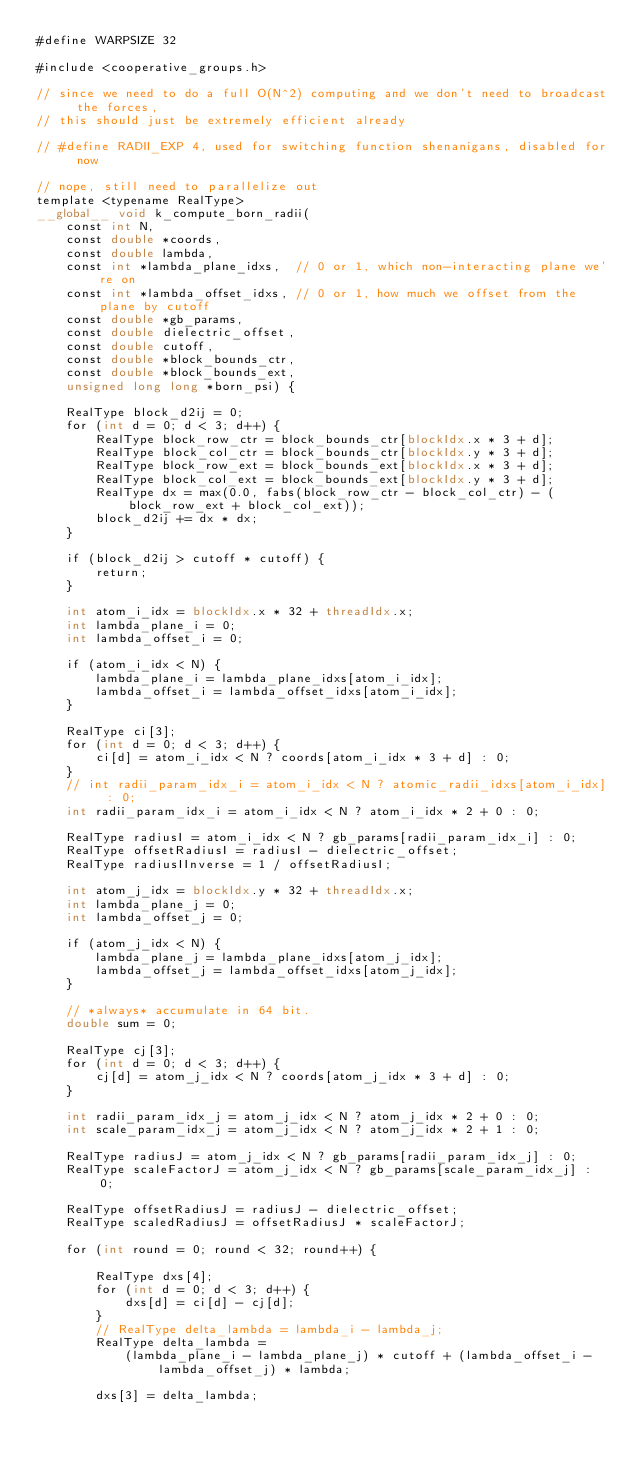<code> <loc_0><loc_0><loc_500><loc_500><_Cuda_>#define WARPSIZE 32

#include <cooperative_groups.h>

// since we need to do a full O(N^2) computing and we don't need to broadcast the forces,
// this should just be extremely efficient already

// #define RADII_EXP 4, used for switching function shenanigans, disabled for now

// nope, still need to parallelize out
template <typename RealType>
__global__ void k_compute_born_radii(
    const int N,
    const double *coords,
    const double lambda,
    const int *lambda_plane_idxs,  // 0 or 1, which non-interacting plane we're on
    const int *lambda_offset_idxs, // 0 or 1, how much we offset from the plane by cutoff
    const double *gb_params,
    const double dielectric_offset,
    const double cutoff,
    const double *block_bounds_ctr,
    const double *block_bounds_ext,
    unsigned long long *born_psi) {

    RealType block_d2ij = 0;
    for (int d = 0; d < 3; d++) {
        RealType block_row_ctr = block_bounds_ctr[blockIdx.x * 3 + d];
        RealType block_col_ctr = block_bounds_ctr[blockIdx.y * 3 + d];
        RealType block_row_ext = block_bounds_ext[blockIdx.x * 3 + d];
        RealType block_col_ext = block_bounds_ext[blockIdx.y * 3 + d];
        RealType dx = max(0.0, fabs(block_row_ctr - block_col_ctr) - (block_row_ext + block_col_ext));
        block_d2ij += dx * dx;
    }

    if (block_d2ij > cutoff * cutoff) {
        return;
    }

    int atom_i_idx = blockIdx.x * 32 + threadIdx.x;
    int lambda_plane_i = 0;
    int lambda_offset_i = 0;

    if (atom_i_idx < N) {
        lambda_plane_i = lambda_plane_idxs[atom_i_idx];
        lambda_offset_i = lambda_offset_idxs[atom_i_idx];
    }

    RealType ci[3];
    for (int d = 0; d < 3; d++) {
        ci[d] = atom_i_idx < N ? coords[atom_i_idx * 3 + d] : 0;
    }
    // int radii_param_idx_i = atom_i_idx < N ? atomic_radii_idxs[atom_i_idx] : 0;
    int radii_param_idx_i = atom_i_idx < N ? atom_i_idx * 2 + 0 : 0;

    RealType radiusI = atom_i_idx < N ? gb_params[radii_param_idx_i] : 0;
    RealType offsetRadiusI = radiusI - dielectric_offset;
    RealType radiusIInverse = 1 / offsetRadiusI;

    int atom_j_idx = blockIdx.y * 32 + threadIdx.x;
    int lambda_plane_j = 0;
    int lambda_offset_j = 0;

    if (atom_j_idx < N) {
        lambda_plane_j = lambda_plane_idxs[atom_j_idx];
        lambda_offset_j = lambda_offset_idxs[atom_j_idx];
    }

    // *always* accumulate in 64 bit.
    double sum = 0;

    RealType cj[3];
    for (int d = 0; d < 3; d++) {
        cj[d] = atom_j_idx < N ? coords[atom_j_idx * 3 + d] : 0;
    }

    int radii_param_idx_j = atom_j_idx < N ? atom_j_idx * 2 + 0 : 0;
    int scale_param_idx_j = atom_j_idx < N ? atom_j_idx * 2 + 1 : 0;

    RealType radiusJ = atom_j_idx < N ? gb_params[radii_param_idx_j] : 0;
    RealType scaleFactorJ = atom_j_idx < N ? gb_params[scale_param_idx_j] : 0;

    RealType offsetRadiusJ = radiusJ - dielectric_offset;
    RealType scaledRadiusJ = offsetRadiusJ * scaleFactorJ;

    for (int round = 0; round < 32; round++) {

        RealType dxs[4];
        for (int d = 0; d < 3; d++) {
            dxs[d] = ci[d] - cj[d];
        }
        // RealType delta_lambda = lambda_i - lambda_j;
        RealType delta_lambda =
            (lambda_plane_i - lambda_plane_j) * cutoff + (lambda_offset_i - lambda_offset_j) * lambda;

        dxs[3] = delta_lambda;
</code> 